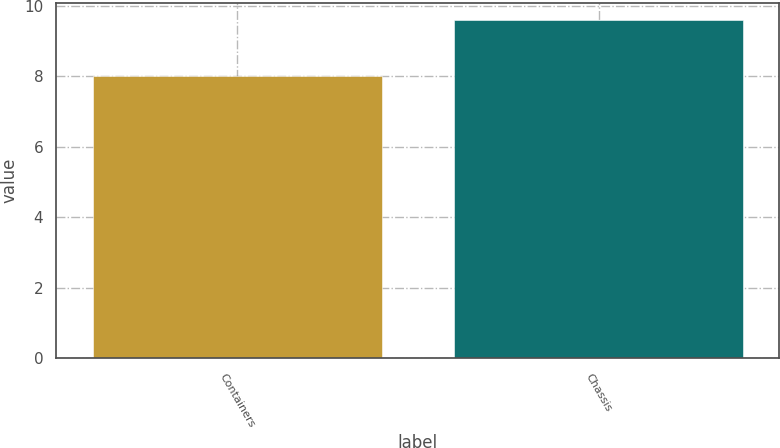Convert chart. <chart><loc_0><loc_0><loc_500><loc_500><bar_chart><fcel>Containers<fcel>Chassis<nl><fcel>8<fcel>9.6<nl></chart> 